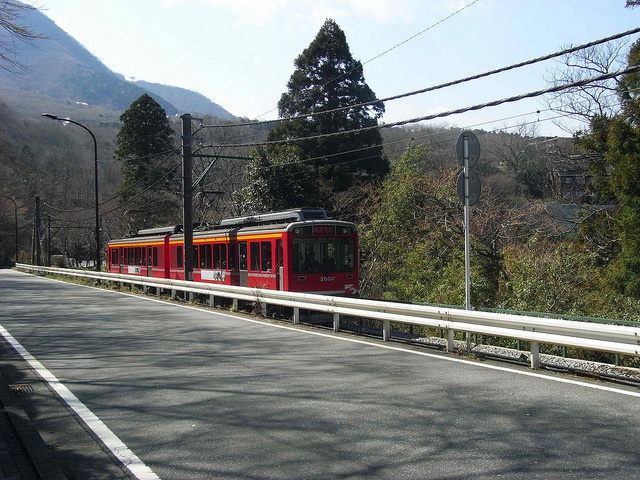Describe the objects in this image and their specific colors. I can see a train in gray, black, maroon, and brown tones in this image. 